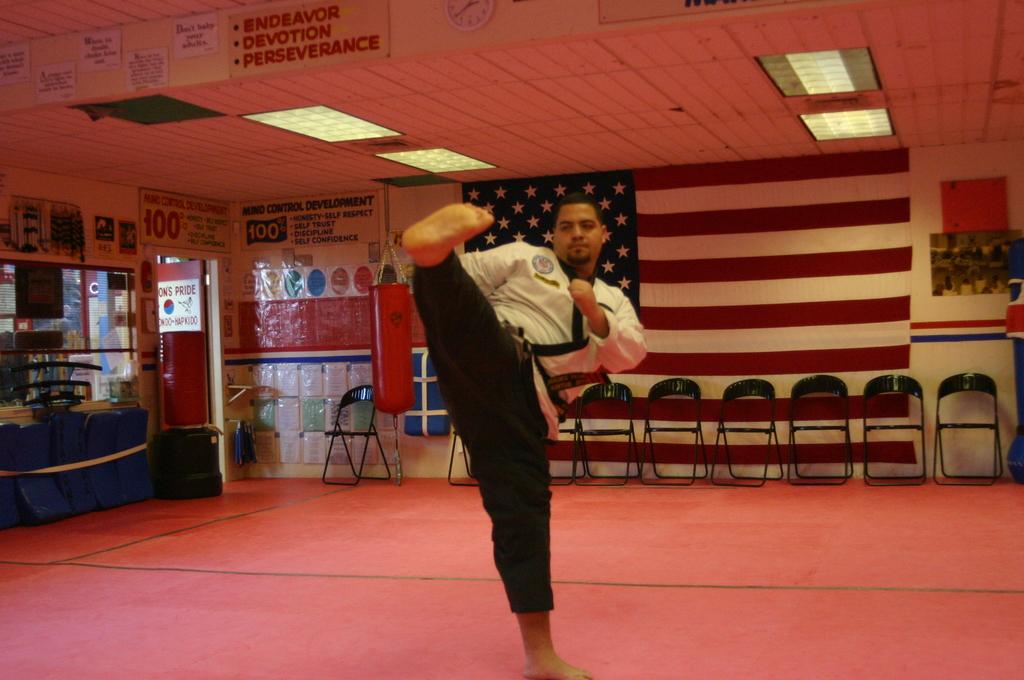What are some of the traits this space encourages, according to their banner?
Make the answer very short. Devotion. What sort of development is listed on the sign?
Offer a terse response. Mind control. 